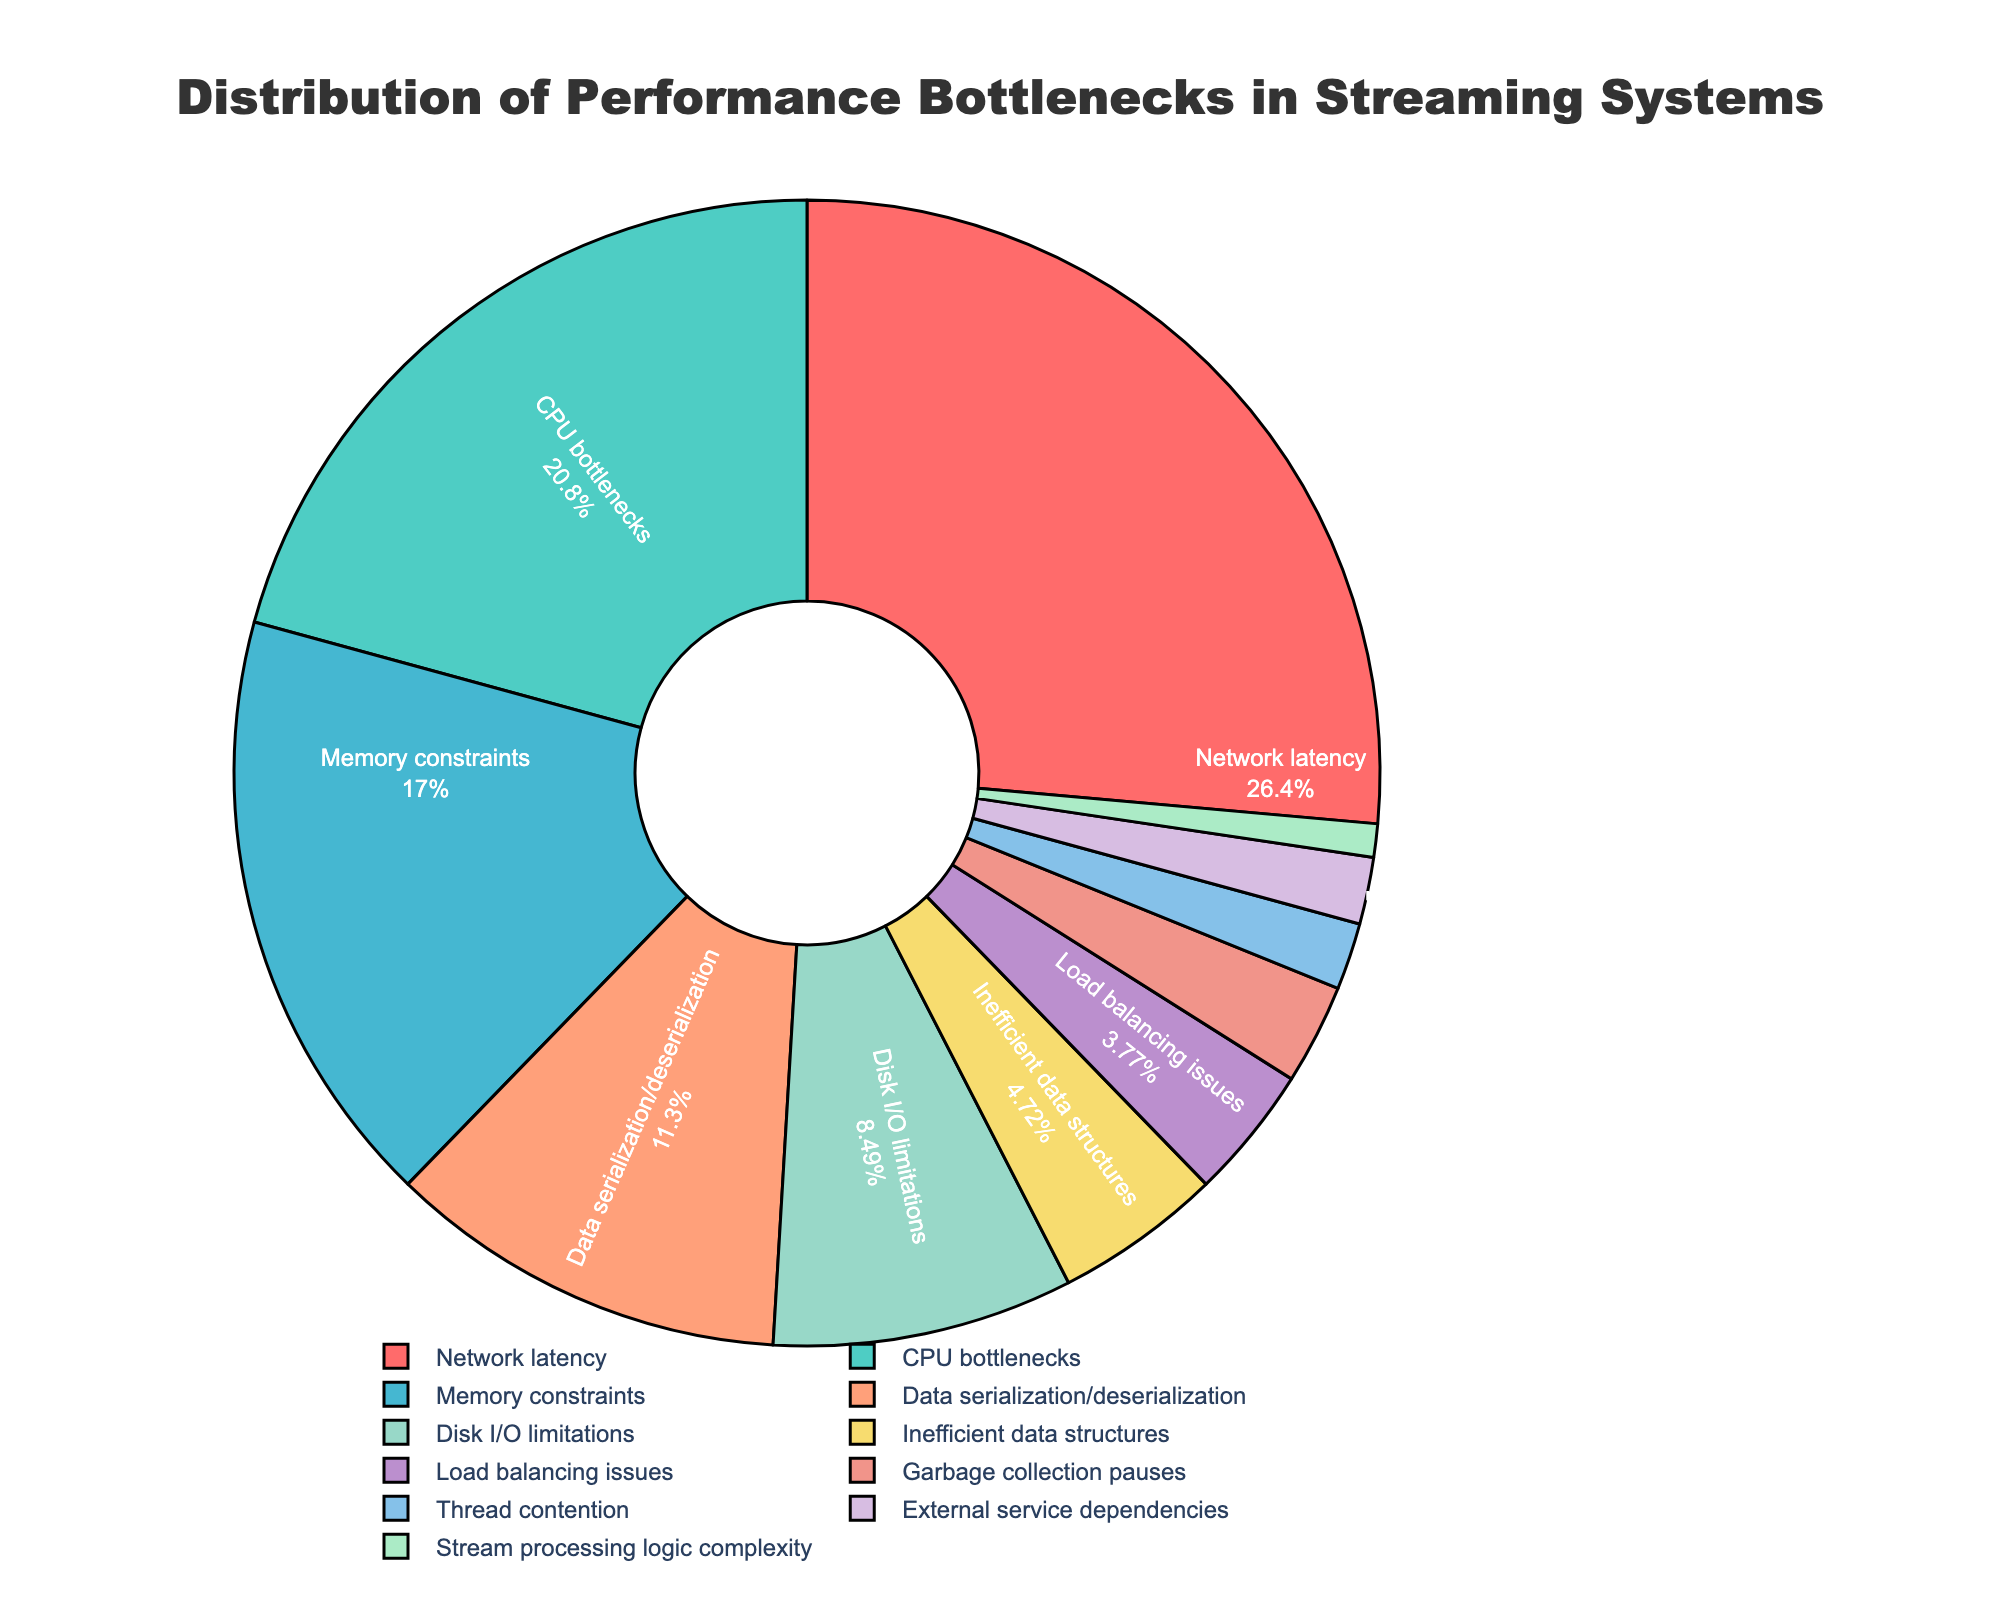What's the largest performance bottleneck in streaming systems according to the pie chart? The largest segment in the pie chart corresponds to "Network latency" with 28%. Since the size of segments visually represents the percentage, the largest segment indicates the largest bottleneck.
Answer: Network latency What is the combined percentage of CPU bottlenecks and Memory constraints? By looking at the pie chart, the segment for "CPU bottlenecks" is 22% and for "Memory constraints" is 18%. Adding these two percentages together, we get 22% + 18% = 40%.
Answer: 40% Which performance bottleneck accounts for less than 5% of the total? The pie chart shows several segments with their percentages, but only categories "Inefficient data structures" (5%), "Load balancing issues" (4%), "Garbage collection pauses" (3%), "Thread contention" (2%), "External service dependencies" (2%), and "Stream processing logic complexity" (1%) are below 5%.
Answer: Inefficient data structures, Load balancing issues, Garbage collection pauses, Thread contention, External service dependencies, Stream processing logic complexity What is the difference in the percentage between Disk I/O limitations and Data serialization/deserialization? The pie chart shows "Disk I/O limitations" as 9% and "Data serialization/deserialization" as 12%. The difference between these two percentages is 12% - 9% = 3%.
Answer: 3% Which category has the highest percentage for performance bottlenecks and by how much does it surpass the lowest category? From the pie chart, "Network latency" is the highest at 28%, and "Stream processing logic complexity" is the lowest at 1%. The difference is 28% - 1% = 27%.
Answer: Network latency by 27% How many categories account for more than 20% of performance bottlenecks? The pie chart shows the percentage for each category, where "Network latency" (28%) and "CPU bottlenecks" (22%) are the only segments greater than 20%.
Answer: 2 What is the average percentage of categories accounting for performance bottlenecks less than 10%? From the pie chart, categories with less than 10% are "Disk I/O limitations" (9%), "Inefficient data structures" (5%), "Load balancing issues" (4%), "Garbage collection pauses" (3%), "Thread contention" (2%), "External service dependencies" (2%), and "Stream processing logic complexity" (1%). The average is calculated as (9% + 5% + 4% + 3% + 2% + 2% + 1%) / 7 = 26% / 7 ≈ 3.71%.
Answer: 3.71% Does Memory constraints have a larger percentage than Data serialization/deserialization? If so, by how much? In the pie chart, "Memory constraints" is shown at 18% and "Data serialization/deserialization" at 12%. The difference is 18% - 12% = 6%.
Answer: Yes, by 6% How many categories are represented with a green color in the chart? By visual inspection, the pie chart includes segments filled with different colors. Only the "Data serialization/deserialization" category appears to be represented with a green color.
Answer: 1 